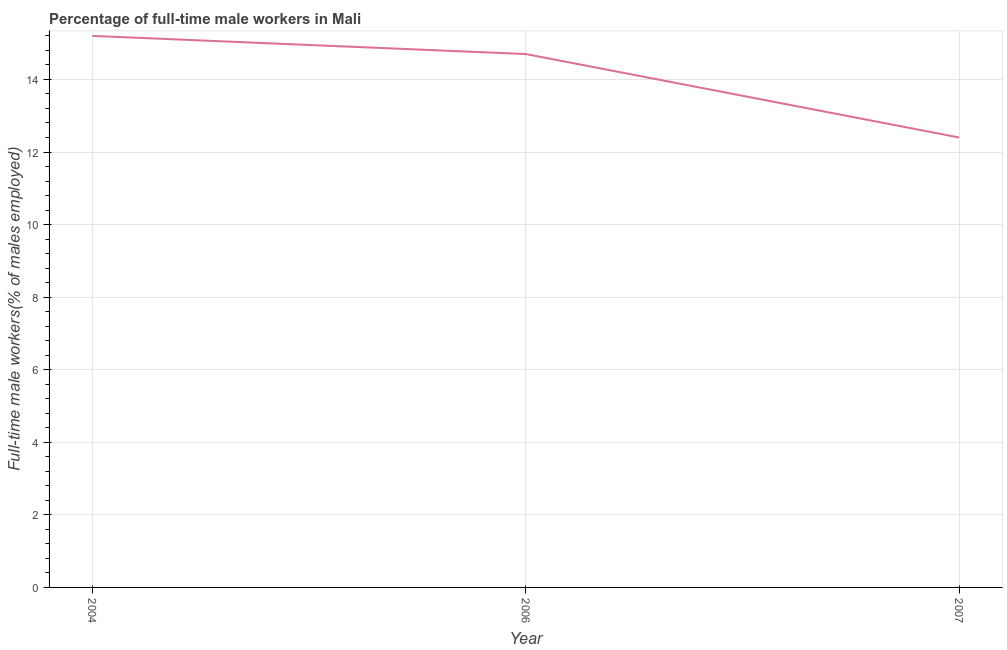What is the percentage of full-time male workers in 2007?
Provide a short and direct response. 12.4. Across all years, what is the maximum percentage of full-time male workers?
Provide a short and direct response. 15.2. Across all years, what is the minimum percentage of full-time male workers?
Provide a short and direct response. 12.4. In which year was the percentage of full-time male workers maximum?
Make the answer very short. 2004. In which year was the percentage of full-time male workers minimum?
Your answer should be compact. 2007. What is the sum of the percentage of full-time male workers?
Provide a succinct answer. 42.3. What is the difference between the percentage of full-time male workers in 2004 and 2007?
Offer a terse response. 2.8. What is the average percentage of full-time male workers per year?
Your response must be concise. 14.1. What is the median percentage of full-time male workers?
Make the answer very short. 14.7. What is the ratio of the percentage of full-time male workers in 2004 to that in 2006?
Your answer should be compact. 1.03. Is the percentage of full-time male workers in 2004 less than that in 2006?
Ensure brevity in your answer.  No. What is the difference between the highest and the second highest percentage of full-time male workers?
Your answer should be compact. 0.5. Is the sum of the percentage of full-time male workers in 2004 and 2006 greater than the maximum percentage of full-time male workers across all years?
Your answer should be compact. Yes. What is the difference between the highest and the lowest percentage of full-time male workers?
Your answer should be very brief. 2.8. In how many years, is the percentage of full-time male workers greater than the average percentage of full-time male workers taken over all years?
Make the answer very short. 2. Does the percentage of full-time male workers monotonically increase over the years?
Your answer should be compact. No. What is the difference between two consecutive major ticks on the Y-axis?
Your answer should be very brief. 2. Does the graph contain any zero values?
Offer a terse response. No. What is the title of the graph?
Give a very brief answer. Percentage of full-time male workers in Mali. What is the label or title of the Y-axis?
Give a very brief answer. Full-time male workers(% of males employed). What is the Full-time male workers(% of males employed) in 2004?
Provide a succinct answer. 15.2. What is the Full-time male workers(% of males employed) in 2006?
Provide a short and direct response. 14.7. What is the Full-time male workers(% of males employed) in 2007?
Offer a very short reply. 12.4. What is the difference between the Full-time male workers(% of males employed) in 2006 and 2007?
Your response must be concise. 2.3. What is the ratio of the Full-time male workers(% of males employed) in 2004 to that in 2006?
Offer a terse response. 1.03. What is the ratio of the Full-time male workers(% of males employed) in 2004 to that in 2007?
Give a very brief answer. 1.23. What is the ratio of the Full-time male workers(% of males employed) in 2006 to that in 2007?
Provide a short and direct response. 1.19. 